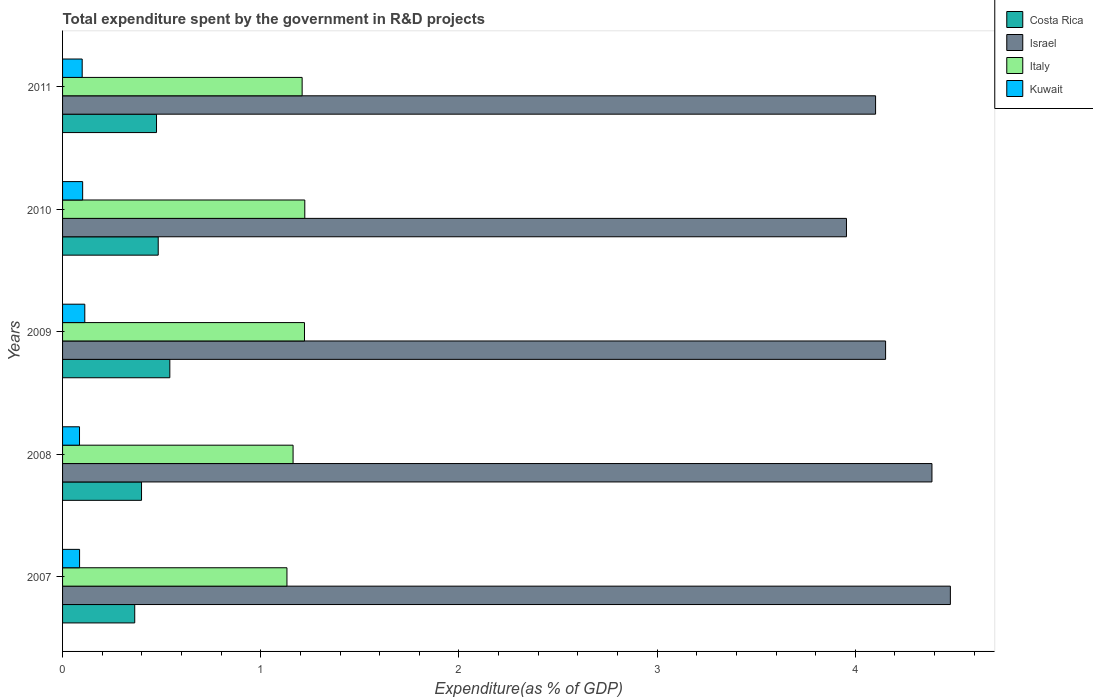How many groups of bars are there?
Your response must be concise. 5. Are the number of bars per tick equal to the number of legend labels?
Provide a short and direct response. Yes. How many bars are there on the 4th tick from the top?
Your answer should be very brief. 4. How many bars are there on the 5th tick from the bottom?
Your response must be concise. 4. In how many cases, is the number of bars for a given year not equal to the number of legend labels?
Ensure brevity in your answer.  0. What is the total expenditure spent by the government in R&D projects in Kuwait in 2008?
Make the answer very short. 0.09. Across all years, what is the maximum total expenditure spent by the government in R&D projects in Israel?
Give a very brief answer. 4.48. Across all years, what is the minimum total expenditure spent by the government in R&D projects in Costa Rica?
Ensure brevity in your answer.  0.36. What is the total total expenditure spent by the government in R&D projects in Israel in the graph?
Your response must be concise. 21.08. What is the difference between the total expenditure spent by the government in R&D projects in Israel in 2008 and that in 2011?
Offer a terse response. 0.28. What is the difference between the total expenditure spent by the government in R&D projects in Costa Rica in 2010 and the total expenditure spent by the government in R&D projects in Israel in 2011?
Offer a very short reply. -3.62. What is the average total expenditure spent by the government in R&D projects in Israel per year?
Your answer should be very brief. 4.22. In the year 2009, what is the difference between the total expenditure spent by the government in R&D projects in Israel and total expenditure spent by the government in R&D projects in Kuwait?
Offer a terse response. 4.04. What is the ratio of the total expenditure spent by the government in R&D projects in Costa Rica in 2010 to that in 2011?
Provide a short and direct response. 1.02. What is the difference between the highest and the second highest total expenditure spent by the government in R&D projects in Costa Rica?
Your answer should be very brief. 0.06. What is the difference between the highest and the lowest total expenditure spent by the government in R&D projects in Israel?
Offer a very short reply. 0.52. Is the sum of the total expenditure spent by the government in R&D projects in Israel in 2007 and 2010 greater than the maximum total expenditure spent by the government in R&D projects in Italy across all years?
Provide a succinct answer. Yes. Is it the case that in every year, the sum of the total expenditure spent by the government in R&D projects in Kuwait and total expenditure spent by the government in R&D projects in Costa Rica is greater than the sum of total expenditure spent by the government in R&D projects in Israel and total expenditure spent by the government in R&D projects in Italy?
Give a very brief answer. Yes. What does the 1st bar from the top in 2011 represents?
Provide a succinct answer. Kuwait. Is it the case that in every year, the sum of the total expenditure spent by the government in R&D projects in Costa Rica and total expenditure spent by the government in R&D projects in Kuwait is greater than the total expenditure spent by the government in R&D projects in Israel?
Your answer should be compact. No. How many bars are there?
Provide a succinct answer. 20. Are all the bars in the graph horizontal?
Keep it short and to the point. Yes. What is the difference between two consecutive major ticks on the X-axis?
Your response must be concise. 1. Are the values on the major ticks of X-axis written in scientific E-notation?
Your answer should be very brief. No. Does the graph contain any zero values?
Offer a very short reply. No. How many legend labels are there?
Your response must be concise. 4. How are the legend labels stacked?
Keep it short and to the point. Vertical. What is the title of the graph?
Give a very brief answer. Total expenditure spent by the government in R&D projects. What is the label or title of the X-axis?
Make the answer very short. Expenditure(as % of GDP). What is the label or title of the Y-axis?
Ensure brevity in your answer.  Years. What is the Expenditure(as % of GDP) in Costa Rica in 2007?
Make the answer very short. 0.36. What is the Expenditure(as % of GDP) of Israel in 2007?
Provide a short and direct response. 4.48. What is the Expenditure(as % of GDP) of Italy in 2007?
Your answer should be very brief. 1.13. What is the Expenditure(as % of GDP) of Kuwait in 2007?
Ensure brevity in your answer.  0.09. What is the Expenditure(as % of GDP) of Costa Rica in 2008?
Offer a terse response. 0.4. What is the Expenditure(as % of GDP) of Israel in 2008?
Provide a succinct answer. 4.39. What is the Expenditure(as % of GDP) of Italy in 2008?
Offer a very short reply. 1.16. What is the Expenditure(as % of GDP) of Kuwait in 2008?
Provide a short and direct response. 0.09. What is the Expenditure(as % of GDP) in Costa Rica in 2009?
Offer a very short reply. 0.54. What is the Expenditure(as % of GDP) of Israel in 2009?
Provide a short and direct response. 4.15. What is the Expenditure(as % of GDP) in Italy in 2009?
Your answer should be very brief. 1.22. What is the Expenditure(as % of GDP) of Kuwait in 2009?
Provide a short and direct response. 0.11. What is the Expenditure(as % of GDP) of Costa Rica in 2010?
Your response must be concise. 0.48. What is the Expenditure(as % of GDP) in Israel in 2010?
Keep it short and to the point. 3.96. What is the Expenditure(as % of GDP) in Italy in 2010?
Make the answer very short. 1.22. What is the Expenditure(as % of GDP) in Kuwait in 2010?
Your answer should be compact. 0.1. What is the Expenditure(as % of GDP) of Costa Rica in 2011?
Offer a terse response. 0.47. What is the Expenditure(as % of GDP) in Israel in 2011?
Give a very brief answer. 4.1. What is the Expenditure(as % of GDP) in Italy in 2011?
Keep it short and to the point. 1.21. What is the Expenditure(as % of GDP) in Kuwait in 2011?
Offer a terse response. 0.1. Across all years, what is the maximum Expenditure(as % of GDP) in Costa Rica?
Make the answer very short. 0.54. Across all years, what is the maximum Expenditure(as % of GDP) of Israel?
Ensure brevity in your answer.  4.48. Across all years, what is the maximum Expenditure(as % of GDP) in Italy?
Give a very brief answer. 1.22. Across all years, what is the maximum Expenditure(as % of GDP) of Kuwait?
Provide a succinct answer. 0.11. Across all years, what is the minimum Expenditure(as % of GDP) of Costa Rica?
Provide a succinct answer. 0.36. Across all years, what is the minimum Expenditure(as % of GDP) of Israel?
Make the answer very short. 3.96. Across all years, what is the minimum Expenditure(as % of GDP) in Italy?
Give a very brief answer. 1.13. Across all years, what is the minimum Expenditure(as % of GDP) in Kuwait?
Ensure brevity in your answer.  0.09. What is the total Expenditure(as % of GDP) in Costa Rica in the graph?
Provide a succinct answer. 2.26. What is the total Expenditure(as % of GDP) in Israel in the graph?
Your answer should be compact. 21.08. What is the total Expenditure(as % of GDP) of Italy in the graph?
Make the answer very short. 5.95. What is the total Expenditure(as % of GDP) in Kuwait in the graph?
Your answer should be very brief. 0.48. What is the difference between the Expenditure(as % of GDP) in Costa Rica in 2007 and that in 2008?
Offer a terse response. -0.03. What is the difference between the Expenditure(as % of GDP) in Israel in 2007 and that in 2008?
Your answer should be very brief. 0.09. What is the difference between the Expenditure(as % of GDP) of Italy in 2007 and that in 2008?
Give a very brief answer. -0.03. What is the difference between the Expenditure(as % of GDP) in Kuwait in 2007 and that in 2008?
Provide a succinct answer. 0. What is the difference between the Expenditure(as % of GDP) of Costa Rica in 2007 and that in 2009?
Ensure brevity in your answer.  -0.18. What is the difference between the Expenditure(as % of GDP) of Israel in 2007 and that in 2009?
Ensure brevity in your answer.  0.33. What is the difference between the Expenditure(as % of GDP) of Italy in 2007 and that in 2009?
Make the answer very short. -0.09. What is the difference between the Expenditure(as % of GDP) in Kuwait in 2007 and that in 2009?
Keep it short and to the point. -0.03. What is the difference between the Expenditure(as % of GDP) of Costa Rica in 2007 and that in 2010?
Provide a succinct answer. -0.12. What is the difference between the Expenditure(as % of GDP) of Israel in 2007 and that in 2010?
Give a very brief answer. 0.52. What is the difference between the Expenditure(as % of GDP) of Italy in 2007 and that in 2010?
Provide a short and direct response. -0.09. What is the difference between the Expenditure(as % of GDP) of Kuwait in 2007 and that in 2010?
Your answer should be very brief. -0.02. What is the difference between the Expenditure(as % of GDP) of Costa Rica in 2007 and that in 2011?
Your answer should be very brief. -0.11. What is the difference between the Expenditure(as % of GDP) in Israel in 2007 and that in 2011?
Keep it short and to the point. 0.38. What is the difference between the Expenditure(as % of GDP) of Italy in 2007 and that in 2011?
Provide a succinct answer. -0.08. What is the difference between the Expenditure(as % of GDP) in Kuwait in 2007 and that in 2011?
Your response must be concise. -0.01. What is the difference between the Expenditure(as % of GDP) of Costa Rica in 2008 and that in 2009?
Offer a terse response. -0.14. What is the difference between the Expenditure(as % of GDP) in Israel in 2008 and that in 2009?
Provide a succinct answer. 0.23. What is the difference between the Expenditure(as % of GDP) of Italy in 2008 and that in 2009?
Give a very brief answer. -0.06. What is the difference between the Expenditure(as % of GDP) of Kuwait in 2008 and that in 2009?
Offer a very short reply. -0.03. What is the difference between the Expenditure(as % of GDP) of Costa Rica in 2008 and that in 2010?
Your answer should be compact. -0.08. What is the difference between the Expenditure(as % of GDP) of Israel in 2008 and that in 2010?
Offer a terse response. 0.43. What is the difference between the Expenditure(as % of GDP) in Italy in 2008 and that in 2010?
Provide a short and direct response. -0.06. What is the difference between the Expenditure(as % of GDP) in Kuwait in 2008 and that in 2010?
Your answer should be very brief. -0.02. What is the difference between the Expenditure(as % of GDP) in Costa Rica in 2008 and that in 2011?
Your response must be concise. -0.08. What is the difference between the Expenditure(as % of GDP) in Israel in 2008 and that in 2011?
Your answer should be very brief. 0.28. What is the difference between the Expenditure(as % of GDP) of Italy in 2008 and that in 2011?
Make the answer very short. -0.05. What is the difference between the Expenditure(as % of GDP) of Kuwait in 2008 and that in 2011?
Offer a very short reply. -0.01. What is the difference between the Expenditure(as % of GDP) in Costa Rica in 2009 and that in 2010?
Your answer should be compact. 0.06. What is the difference between the Expenditure(as % of GDP) in Israel in 2009 and that in 2010?
Provide a short and direct response. 0.2. What is the difference between the Expenditure(as % of GDP) in Italy in 2009 and that in 2010?
Provide a short and direct response. -0. What is the difference between the Expenditure(as % of GDP) of Kuwait in 2009 and that in 2010?
Your answer should be compact. 0.01. What is the difference between the Expenditure(as % of GDP) in Costa Rica in 2009 and that in 2011?
Your answer should be very brief. 0.07. What is the difference between the Expenditure(as % of GDP) of Israel in 2009 and that in 2011?
Give a very brief answer. 0.05. What is the difference between the Expenditure(as % of GDP) in Italy in 2009 and that in 2011?
Give a very brief answer. 0.01. What is the difference between the Expenditure(as % of GDP) in Kuwait in 2009 and that in 2011?
Ensure brevity in your answer.  0.01. What is the difference between the Expenditure(as % of GDP) in Costa Rica in 2010 and that in 2011?
Your response must be concise. 0.01. What is the difference between the Expenditure(as % of GDP) of Israel in 2010 and that in 2011?
Ensure brevity in your answer.  -0.15. What is the difference between the Expenditure(as % of GDP) of Italy in 2010 and that in 2011?
Make the answer very short. 0.01. What is the difference between the Expenditure(as % of GDP) of Kuwait in 2010 and that in 2011?
Offer a very short reply. 0. What is the difference between the Expenditure(as % of GDP) in Costa Rica in 2007 and the Expenditure(as % of GDP) in Israel in 2008?
Provide a succinct answer. -4.02. What is the difference between the Expenditure(as % of GDP) of Costa Rica in 2007 and the Expenditure(as % of GDP) of Italy in 2008?
Your answer should be compact. -0.8. What is the difference between the Expenditure(as % of GDP) of Costa Rica in 2007 and the Expenditure(as % of GDP) of Kuwait in 2008?
Offer a terse response. 0.28. What is the difference between the Expenditure(as % of GDP) of Israel in 2007 and the Expenditure(as % of GDP) of Italy in 2008?
Keep it short and to the point. 3.32. What is the difference between the Expenditure(as % of GDP) in Israel in 2007 and the Expenditure(as % of GDP) in Kuwait in 2008?
Provide a short and direct response. 4.39. What is the difference between the Expenditure(as % of GDP) in Italy in 2007 and the Expenditure(as % of GDP) in Kuwait in 2008?
Your response must be concise. 1.05. What is the difference between the Expenditure(as % of GDP) in Costa Rica in 2007 and the Expenditure(as % of GDP) in Israel in 2009?
Provide a succinct answer. -3.79. What is the difference between the Expenditure(as % of GDP) of Costa Rica in 2007 and the Expenditure(as % of GDP) of Italy in 2009?
Provide a short and direct response. -0.86. What is the difference between the Expenditure(as % of GDP) in Costa Rica in 2007 and the Expenditure(as % of GDP) in Kuwait in 2009?
Make the answer very short. 0.25. What is the difference between the Expenditure(as % of GDP) of Israel in 2007 and the Expenditure(as % of GDP) of Italy in 2009?
Your answer should be very brief. 3.26. What is the difference between the Expenditure(as % of GDP) of Israel in 2007 and the Expenditure(as % of GDP) of Kuwait in 2009?
Provide a short and direct response. 4.37. What is the difference between the Expenditure(as % of GDP) in Costa Rica in 2007 and the Expenditure(as % of GDP) in Israel in 2010?
Ensure brevity in your answer.  -3.59. What is the difference between the Expenditure(as % of GDP) in Costa Rica in 2007 and the Expenditure(as % of GDP) in Italy in 2010?
Keep it short and to the point. -0.86. What is the difference between the Expenditure(as % of GDP) in Costa Rica in 2007 and the Expenditure(as % of GDP) in Kuwait in 2010?
Keep it short and to the point. 0.26. What is the difference between the Expenditure(as % of GDP) of Israel in 2007 and the Expenditure(as % of GDP) of Italy in 2010?
Your answer should be compact. 3.26. What is the difference between the Expenditure(as % of GDP) of Israel in 2007 and the Expenditure(as % of GDP) of Kuwait in 2010?
Make the answer very short. 4.38. What is the difference between the Expenditure(as % of GDP) in Italy in 2007 and the Expenditure(as % of GDP) in Kuwait in 2010?
Provide a succinct answer. 1.03. What is the difference between the Expenditure(as % of GDP) in Costa Rica in 2007 and the Expenditure(as % of GDP) in Israel in 2011?
Offer a terse response. -3.74. What is the difference between the Expenditure(as % of GDP) in Costa Rica in 2007 and the Expenditure(as % of GDP) in Italy in 2011?
Your answer should be compact. -0.84. What is the difference between the Expenditure(as % of GDP) in Costa Rica in 2007 and the Expenditure(as % of GDP) in Kuwait in 2011?
Provide a short and direct response. 0.27. What is the difference between the Expenditure(as % of GDP) of Israel in 2007 and the Expenditure(as % of GDP) of Italy in 2011?
Make the answer very short. 3.27. What is the difference between the Expenditure(as % of GDP) of Israel in 2007 and the Expenditure(as % of GDP) of Kuwait in 2011?
Your answer should be very brief. 4.38. What is the difference between the Expenditure(as % of GDP) in Italy in 2007 and the Expenditure(as % of GDP) in Kuwait in 2011?
Offer a very short reply. 1.03. What is the difference between the Expenditure(as % of GDP) of Costa Rica in 2008 and the Expenditure(as % of GDP) of Israel in 2009?
Your answer should be compact. -3.75. What is the difference between the Expenditure(as % of GDP) in Costa Rica in 2008 and the Expenditure(as % of GDP) in Italy in 2009?
Give a very brief answer. -0.82. What is the difference between the Expenditure(as % of GDP) in Costa Rica in 2008 and the Expenditure(as % of GDP) in Kuwait in 2009?
Ensure brevity in your answer.  0.29. What is the difference between the Expenditure(as % of GDP) of Israel in 2008 and the Expenditure(as % of GDP) of Italy in 2009?
Make the answer very short. 3.17. What is the difference between the Expenditure(as % of GDP) of Israel in 2008 and the Expenditure(as % of GDP) of Kuwait in 2009?
Provide a short and direct response. 4.27. What is the difference between the Expenditure(as % of GDP) in Italy in 2008 and the Expenditure(as % of GDP) in Kuwait in 2009?
Keep it short and to the point. 1.05. What is the difference between the Expenditure(as % of GDP) of Costa Rica in 2008 and the Expenditure(as % of GDP) of Israel in 2010?
Provide a succinct answer. -3.56. What is the difference between the Expenditure(as % of GDP) of Costa Rica in 2008 and the Expenditure(as % of GDP) of Italy in 2010?
Ensure brevity in your answer.  -0.82. What is the difference between the Expenditure(as % of GDP) in Costa Rica in 2008 and the Expenditure(as % of GDP) in Kuwait in 2010?
Ensure brevity in your answer.  0.3. What is the difference between the Expenditure(as % of GDP) in Israel in 2008 and the Expenditure(as % of GDP) in Italy in 2010?
Offer a very short reply. 3.16. What is the difference between the Expenditure(as % of GDP) of Israel in 2008 and the Expenditure(as % of GDP) of Kuwait in 2010?
Keep it short and to the point. 4.29. What is the difference between the Expenditure(as % of GDP) in Italy in 2008 and the Expenditure(as % of GDP) in Kuwait in 2010?
Provide a succinct answer. 1.06. What is the difference between the Expenditure(as % of GDP) of Costa Rica in 2008 and the Expenditure(as % of GDP) of Israel in 2011?
Your response must be concise. -3.7. What is the difference between the Expenditure(as % of GDP) in Costa Rica in 2008 and the Expenditure(as % of GDP) in Italy in 2011?
Offer a very short reply. -0.81. What is the difference between the Expenditure(as % of GDP) in Costa Rica in 2008 and the Expenditure(as % of GDP) in Kuwait in 2011?
Offer a very short reply. 0.3. What is the difference between the Expenditure(as % of GDP) of Israel in 2008 and the Expenditure(as % of GDP) of Italy in 2011?
Provide a succinct answer. 3.18. What is the difference between the Expenditure(as % of GDP) in Israel in 2008 and the Expenditure(as % of GDP) in Kuwait in 2011?
Ensure brevity in your answer.  4.29. What is the difference between the Expenditure(as % of GDP) in Italy in 2008 and the Expenditure(as % of GDP) in Kuwait in 2011?
Keep it short and to the point. 1.06. What is the difference between the Expenditure(as % of GDP) in Costa Rica in 2009 and the Expenditure(as % of GDP) in Israel in 2010?
Offer a terse response. -3.41. What is the difference between the Expenditure(as % of GDP) in Costa Rica in 2009 and the Expenditure(as % of GDP) in Italy in 2010?
Ensure brevity in your answer.  -0.68. What is the difference between the Expenditure(as % of GDP) of Costa Rica in 2009 and the Expenditure(as % of GDP) of Kuwait in 2010?
Give a very brief answer. 0.44. What is the difference between the Expenditure(as % of GDP) of Israel in 2009 and the Expenditure(as % of GDP) of Italy in 2010?
Keep it short and to the point. 2.93. What is the difference between the Expenditure(as % of GDP) of Israel in 2009 and the Expenditure(as % of GDP) of Kuwait in 2010?
Offer a terse response. 4.05. What is the difference between the Expenditure(as % of GDP) in Italy in 2009 and the Expenditure(as % of GDP) in Kuwait in 2010?
Offer a terse response. 1.12. What is the difference between the Expenditure(as % of GDP) in Costa Rica in 2009 and the Expenditure(as % of GDP) in Israel in 2011?
Provide a short and direct response. -3.56. What is the difference between the Expenditure(as % of GDP) of Costa Rica in 2009 and the Expenditure(as % of GDP) of Italy in 2011?
Your answer should be compact. -0.67. What is the difference between the Expenditure(as % of GDP) in Costa Rica in 2009 and the Expenditure(as % of GDP) in Kuwait in 2011?
Make the answer very short. 0.44. What is the difference between the Expenditure(as % of GDP) of Israel in 2009 and the Expenditure(as % of GDP) of Italy in 2011?
Your answer should be very brief. 2.94. What is the difference between the Expenditure(as % of GDP) in Israel in 2009 and the Expenditure(as % of GDP) in Kuwait in 2011?
Make the answer very short. 4.05. What is the difference between the Expenditure(as % of GDP) in Italy in 2009 and the Expenditure(as % of GDP) in Kuwait in 2011?
Your answer should be very brief. 1.12. What is the difference between the Expenditure(as % of GDP) of Costa Rica in 2010 and the Expenditure(as % of GDP) of Israel in 2011?
Provide a succinct answer. -3.62. What is the difference between the Expenditure(as % of GDP) in Costa Rica in 2010 and the Expenditure(as % of GDP) in Italy in 2011?
Offer a terse response. -0.73. What is the difference between the Expenditure(as % of GDP) of Costa Rica in 2010 and the Expenditure(as % of GDP) of Kuwait in 2011?
Offer a terse response. 0.38. What is the difference between the Expenditure(as % of GDP) in Israel in 2010 and the Expenditure(as % of GDP) in Italy in 2011?
Keep it short and to the point. 2.75. What is the difference between the Expenditure(as % of GDP) of Israel in 2010 and the Expenditure(as % of GDP) of Kuwait in 2011?
Your answer should be very brief. 3.86. What is the difference between the Expenditure(as % of GDP) of Italy in 2010 and the Expenditure(as % of GDP) of Kuwait in 2011?
Offer a terse response. 1.12. What is the average Expenditure(as % of GDP) of Costa Rica per year?
Give a very brief answer. 0.45. What is the average Expenditure(as % of GDP) of Israel per year?
Your answer should be compact. 4.22. What is the average Expenditure(as % of GDP) in Italy per year?
Your response must be concise. 1.19. What is the average Expenditure(as % of GDP) of Kuwait per year?
Your answer should be very brief. 0.1. In the year 2007, what is the difference between the Expenditure(as % of GDP) in Costa Rica and Expenditure(as % of GDP) in Israel?
Your answer should be compact. -4.12. In the year 2007, what is the difference between the Expenditure(as % of GDP) in Costa Rica and Expenditure(as % of GDP) in Italy?
Ensure brevity in your answer.  -0.77. In the year 2007, what is the difference between the Expenditure(as % of GDP) in Costa Rica and Expenditure(as % of GDP) in Kuwait?
Give a very brief answer. 0.28. In the year 2007, what is the difference between the Expenditure(as % of GDP) of Israel and Expenditure(as % of GDP) of Italy?
Offer a terse response. 3.35. In the year 2007, what is the difference between the Expenditure(as % of GDP) in Israel and Expenditure(as % of GDP) in Kuwait?
Give a very brief answer. 4.39. In the year 2007, what is the difference between the Expenditure(as % of GDP) of Italy and Expenditure(as % of GDP) of Kuwait?
Make the answer very short. 1.05. In the year 2008, what is the difference between the Expenditure(as % of GDP) in Costa Rica and Expenditure(as % of GDP) in Israel?
Give a very brief answer. -3.99. In the year 2008, what is the difference between the Expenditure(as % of GDP) in Costa Rica and Expenditure(as % of GDP) in Italy?
Offer a very short reply. -0.76. In the year 2008, what is the difference between the Expenditure(as % of GDP) in Costa Rica and Expenditure(as % of GDP) in Kuwait?
Your response must be concise. 0.31. In the year 2008, what is the difference between the Expenditure(as % of GDP) in Israel and Expenditure(as % of GDP) in Italy?
Your answer should be very brief. 3.22. In the year 2008, what is the difference between the Expenditure(as % of GDP) in Israel and Expenditure(as % of GDP) in Kuwait?
Provide a short and direct response. 4.3. In the year 2008, what is the difference between the Expenditure(as % of GDP) of Italy and Expenditure(as % of GDP) of Kuwait?
Keep it short and to the point. 1.08. In the year 2009, what is the difference between the Expenditure(as % of GDP) in Costa Rica and Expenditure(as % of GDP) in Israel?
Make the answer very short. -3.61. In the year 2009, what is the difference between the Expenditure(as % of GDP) of Costa Rica and Expenditure(as % of GDP) of Italy?
Your answer should be compact. -0.68. In the year 2009, what is the difference between the Expenditure(as % of GDP) of Costa Rica and Expenditure(as % of GDP) of Kuwait?
Make the answer very short. 0.43. In the year 2009, what is the difference between the Expenditure(as % of GDP) in Israel and Expenditure(as % of GDP) in Italy?
Your answer should be very brief. 2.93. In the year 2009, what is the difference between the Expenditure(as % of GDP) in Israel and Expenditure(as % of GDP) in Kuwait?
Your answer should be compact. 4.04. In the year 2009, what is the difference between the Expenditure(as % of GDP) in Italy and Expenditure(as % of GDP) in Kuwait?
Ensure brevity in your answer.  1.11. In the year 2010, what is the difference between the Expenditure(as % of GDP) in Costa Rica and Expenditure(as % of GDP) in Israel?
Your answer should be compact. -3.47. In the year 2010, what is the difference between the Expenditure(as % of GDP) of Costa Rica and Expenditure(as % of GDP) of Italy?
Your answer should be very brief. -0.74. In the year 2010, what is the difference between the Expenditure(as % of GDP) of Costa Rica and Expenditure(as % of GDP) of Kuwait?
Your response must be concise. 0.38. In the year 2010, what is the difference between the Expenditure(as % of GDP) of Israel and Expenditure(as % of GDP) of Italy?
Your answer should be compact. 2.73. In the year 2010, what is the difference between the Expenditure(as % of GDP) of Israel and Expenditure(as % of GDP) of Kuwait?
Keep it short and to the point. 3.85. In the year 2010, what is the difference between the Expenditure(as % of GDP) of Italy and Expenditure(as % of GDP) of Kuwait?
Make the answer very short. 1.12. In the year 2011, what is the difference between the Expenditure(as % of GDP) in Costa Rica and Expenditure(as % of GDP) in Israel?
Your response must be concise. -3.63. In the year 2011, what is the difference between the Expenditure(as % of GDP) in Costa Rica and Expenditure(as % of GDP) in Italy?
Offer a terse response. -0.73. In the year 2011, what is the difference between the Expenditure(as % of GDP) of Israel and Expenditure(as % of GDP) of Italy?
Give a very brief answer. 2.89. In the year 2011, what is the difference between the Expenditure(as % of GDP) of Israel and Expenditure(as % of GDP) of Kuwait?
Ensure brevity in your answer.  4. In the year 2011, what is the difference between the Expenditure(as % of GDP) in Italy and Expenditure(as % of GDP) in Kuwait?
Keep it short and to the point. 1.11. What is the ratio of the Expenditure(as % of GDP) of Costa Rica in 2007 to that in 2008?
Your answer should be very brief. 0.91. What is the ratio of the Expenditure(as % of GDP) of Israel in 2007 to that in 2008?
Offer a very short reply. 1.02. What is the ratio of the Expenditure(as % of GDP) of Italy in 2007 to that in 2008?
Your answer should be compact. 0.97. What is the ratio of the Expenditure(as % of GDP) of Kuwait in 2007 to that in 2008?
Your answer should be very brief. 1. What is the ratio of the Expenditure(as % of GDP) in Costa Rica in 2007 to that in 2009?
Your answer should be compact. 0.67. What is the ratio of the Expenditure(as % of GDP) of Israel in 2007 to that in 2009?
Provide a succinct answer. 1.08. What is the ratio of the Expenditure(as % of GDP) in Italy in 2007 to that in 2009?
Make the answer very short. 0.93. What is the ratio of the Expenditure(as % of GDP) in Kuwait in 2007 to that in 2009?
Make the answer very short. 0.77. What is the ratio of the Expenditure(as % of GDP) in Costa Rica in 2007 to that in 2010?
Keep it short and to the point. 0.75. What is the ratio of the Expenditure(as % of GDP) of Israel in 2007 to that in 2010?
Offer a very short reply. 1.13. What is the ratio of the Expenditure(as % of GDP) in Italy in 2007 to that in 2010?
Provide a short and direct response. 0.93. What is the ratio of the Expenditure(as % of GDP) of Kuwait in 2007 to that in 2010?
Your response must be concise. 0.85. What is the ratio of the Expenditure(as % of GDP) in Costa Rica in 2007 to that in 2011?
Your response must be concise. 0.77. What is the ratio of the Expenditure(as % of GDP) in Israel in 2007 to that in 2011?
Give a very brief answer. 1.09. What is the ratio of the Expenditure(as % of GDP) in Italy in 2007 to that in 2011?
Make the answer very short. 0.94. What is the ratio of the Expenditure(as % of GDP) in Kuwait in 2007 to that in 2011?
Keep it short and to the point. 0.87. What is the ratio of the Expenditure(as % of GDP) in Costa Rica in 2008 to that in 2009?
Make the answer very short. 0.74. What is the ratio of the Expenditure(as % of GDP) of Israel in 2008 to that in 2009?
Your answer should be compact. 1.06. What is the ratio of the Expenditure(as % of GDP) in Italy in 2008 to that in 2009?
Offer a very short reply. 0.95. What is the ratio of the Expenditure(as % of GDP) in Kuwait in 2008 to that in 2009?
Offer a very short reply. 0.76. What is the ratio of the Expenditure(as % of GDP) of Costa Rica in 2008 to that in 2010?
Provide a succinct answer. 0.83. What is the ratio of the Expenditure(as % of GDP) in Israel in 2008 to that in 2010?
Give a very brief answer. 1.11. What is the ratio of the Expenditure(as % of GDP) in Italy in 2008 to that in 2010?
Provide a succinct answer. 0.95. What is the ratio of the Expenditure(as % of GDP) in Kuwait in 2008 to that in 2010?
Give a very brief answer. 0.84. What is the ratio of the Expenditure(as % of GDP) of Costa Rica in 2008 to that in 2011?
Provide a short and direct response. 0.84. What is the ratio of the Expenditure(as % of GDP) of Israel in 2008 to that in 2011?
Keep it short and to the point. 1.07. What is the ratio of the Expenditure(as % of GDP) of Italy in 2008 to that in 2011?
Make the answer very short. 0.96. What is the ratio of the Expenditure(as % of GDP) in Kuwait in 2008 to that in 2011?
Provide a succinct answer. 0.86. What is the ratio of the Expenditure(as % of GDP) of Costa Rica in 2009 to that in 2010?
Your answer should be compact. 1.12. What is the ratio of the Expenditure(as % of GDP) in Israel in 2009 to that in 2010?
Provide a short and direct response. 1.05. What is the ratio of the Expenditure(as % of GDP) of Italy in 2009 to that in 2010?
Your answer should be very brief. 1. What is the ratio of the Expenditure(as % of GDP) in Kuwait in 2009 to that in 2010?
Ensure brevity in your answer.  1.11. What is the ratio of the Expenditure(as % of GDP) of Costa Rica in 2009 to that in 2011?
Provide a succinct answer. 1.14. What is the ratio of the Expenditure(as % of GDP) of Israel in 2009 to that in 2011?
Make the answer very short. 1.01. What is the ratio of the Expenditure(as % of GDP) in Italy in 2009 to that in 2011?
Your response must be concise. 1.01. What is the ratio of the Expenditure(as % of GDP) in Kuwait in 2009 to that in 2011?
Ensure brevity in your answer.  1.13. What is the ratio of the Expenditure(as % of GDP) in Costa Rica in 2010 to that in 2011?
Keep it short and to the point. 1.02. What is the ratio of the Expenditure(as % of GDP) of Israel in 2010 to that in 2011?
Make the answer very short. 0.96. What is the ratio of the Expenditure(as % of GDP) of Italy in 2010 to that in 2011?
Offer a terse response. 1.01. What is the ratio of the Expenditure(as % of GDP) of Kuwait in 2010 to that in 2011?
Your answer should be very brief. 1.02. What is the difference between the highest and the second highest Expenditure(as % of GDP) in Costa Rica?
Provide a short and direct response. 0.06. What is the difference between the highest and the second highest Expenditure(as % of GDP) of Israel?
Make the answer very short. 0.09. What is the difference between the highest and the second highest Expenditure(as % of GDP) in Italy?
Ensure brevity in your answer.  0. What is the difference between the highest and the second highest Expenditure(as % of GDP) of Kuwait?
Give a very brief answer. 0.01. What is the difference between the highest and the lowest Expenditure(as % of GDP) in Costa Rica?
Give a very brief answer. 0.18. What is the difference between the highest and the lowest Expenditure(as % of GDP) of Israel?
Ensure brevity in your answer.  0.52. What is the difference between the highest and the lowest Expenditure(as % of GDP) in Italy?
Ensure brevity in your answer.  0.09. What is the difference between the highest and the lowest Expenditure(as % of GDP) of Kuwait?
Provide a succinct answer. 0.03. 